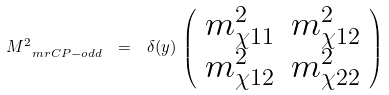<formula> <loc_0><loc_0><loc_500><loc_500>M _ { \ m r { C P - o d d } } ^ { 2 } \ = \ \delta ( y ) \, \left ( \begin{array} { c c } m ^ { 2 } _ { \chi 1 1 } & m ^ { 2 } _ { \chi 1 2 } \\ m ^ { 2 } _ { \chi 1 2 } & m ^ { 2 } _ { \chi 2 2 } \\ \end{array} \right ) \ \,</formula> 